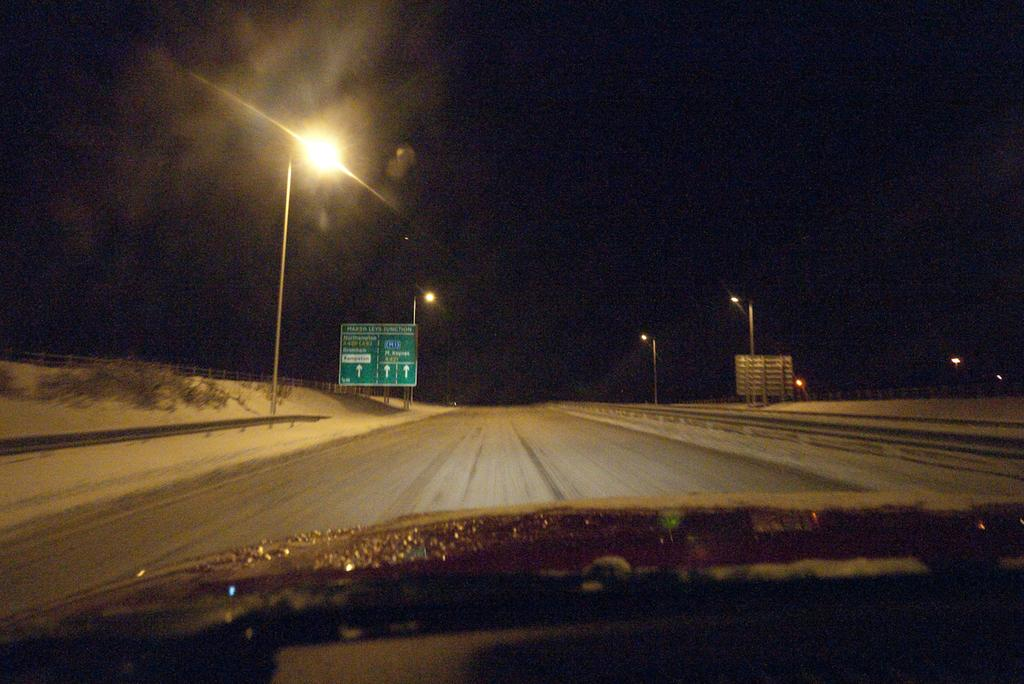What is the main subject of the image? The main subject of the image is a car. Where is the car located in the image? The car is on the road in the image. What can be seen on either side of the road? Street lights are present on either side of the road. What time of day is depicted in the image? The image was taken at night time. Can you tell me how many scarecrows are standing near the car in the image? There are no scarecrows present in the image; it features a car on the road at night time with street lights on either side. What action is the car performing in the image? The car is not performing any action in the image; it is simply parked or driving on the road. 